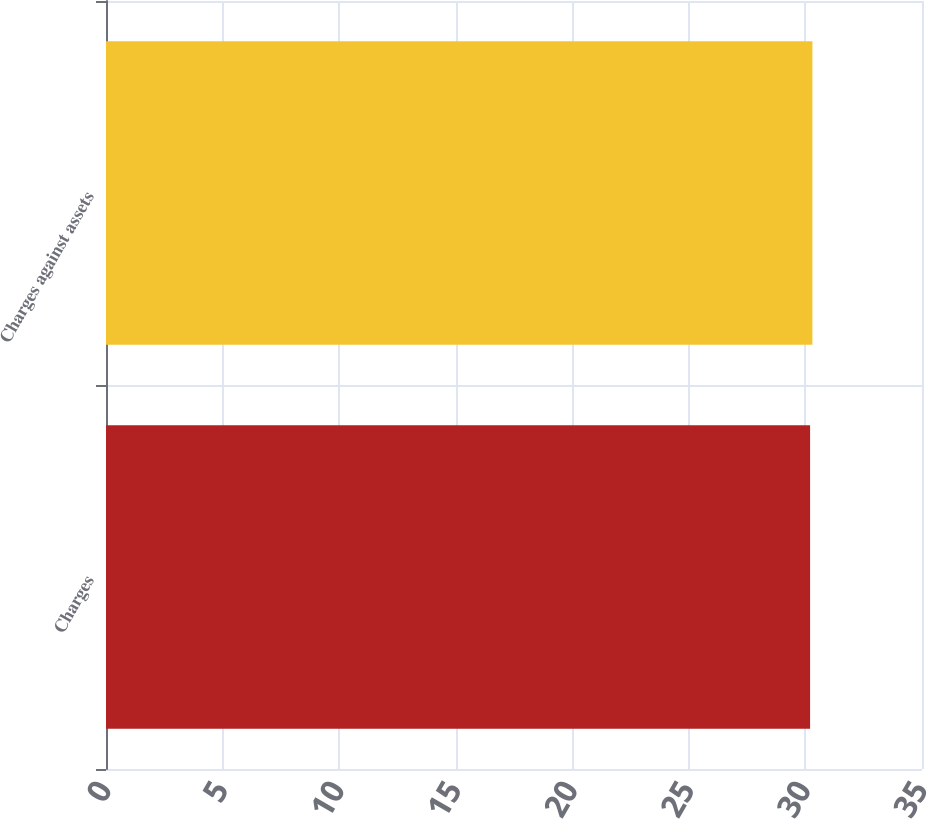Convert chart. <chart><loc_0><loc_0><loc_500><loc_500><bar_chart><fcel>Charges<fcel>Charges against assets<nl><fcel>30.2<fcel>30.3<nl></chart> 